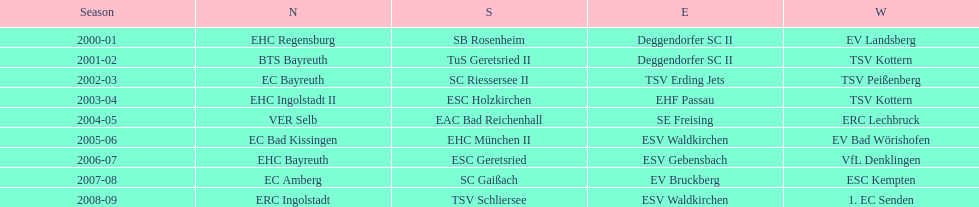What is the number of seasons covered in the table? 9. 